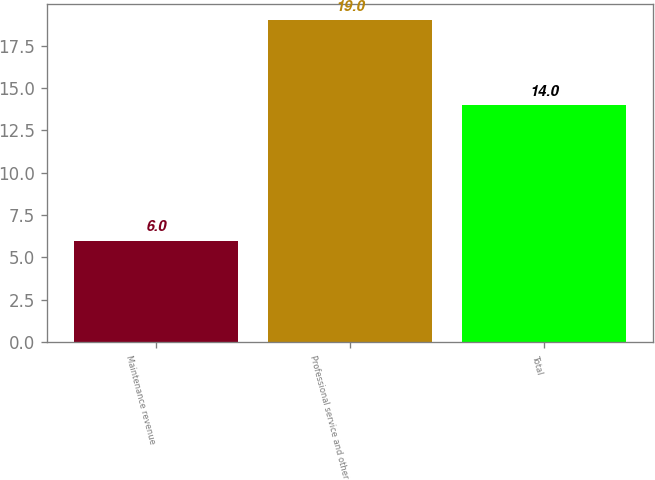Convert chart to OTSL. <chart><loc_0><loc_0><loc_500><loc_500><bar_chart><fcel>Maintenance revenue<fcel>Professional service and other<fcel>Total<nl><fcel>6<fcel>19<fcel>14<nl></chart> 